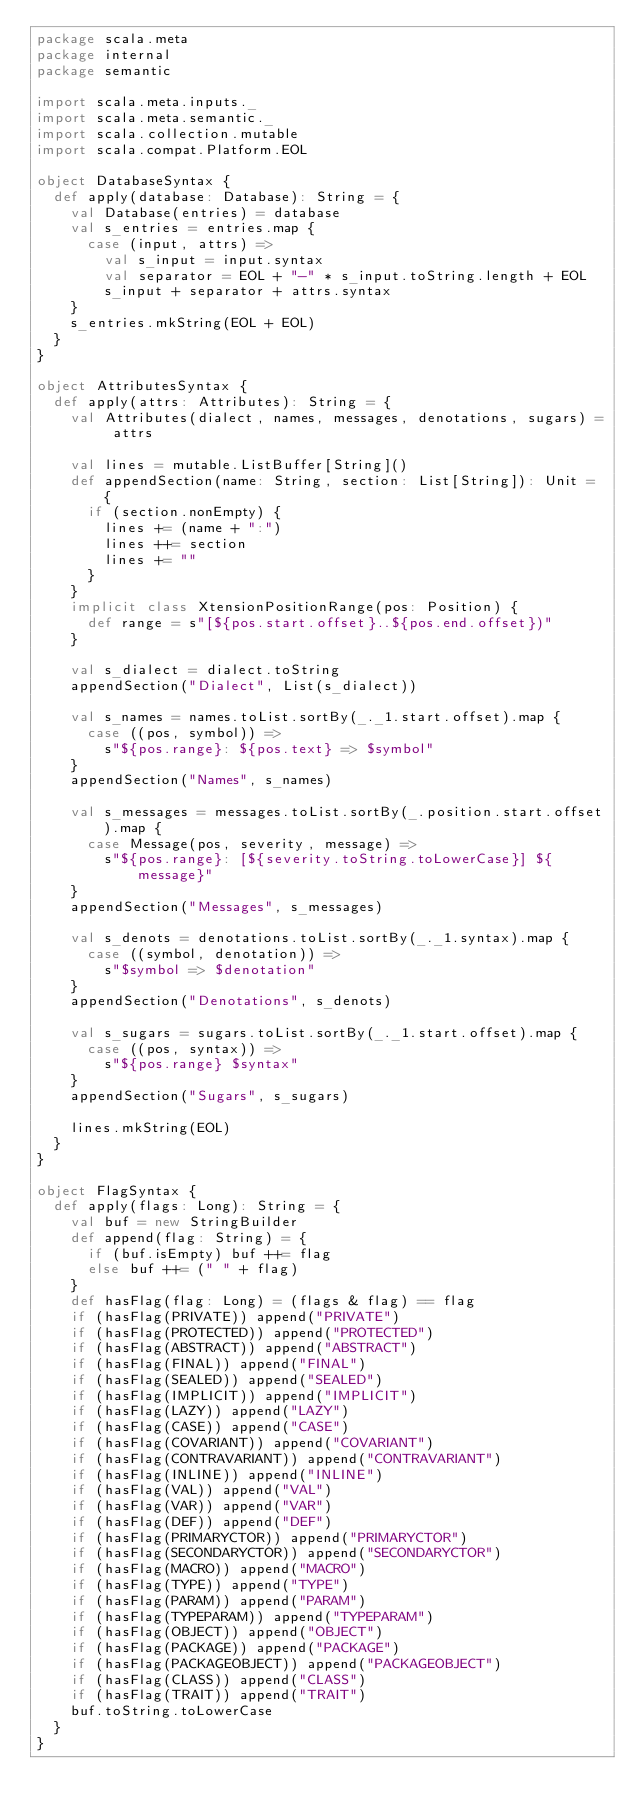Convert code to text. <code><loc_0><loc_0><loc_500><loc_500><_Scala_>package scala.meta
package internal
package semantic

import scala.meta.inputs._
import scala.meta.semantic._
import scala.collection.mutable
import scala.compat.Platform.EOL

object DatabaseSyntax {
  def apply(database: Database): String = {
    val Database(entries) = database
    val s_entries = entries.map {
      case (input, attrs) =>
        val s_input = input.syntax
        val separator = EOL + "-" * s_input.toString.length + EOL
        s_input + separator + attrs.syntax
    }
    s_entries.mkString(EOL + EOL)
  }
}

object AttributesSyntax {
  def apply(attrs: Attributes): String = {
    val Attributes(dialect, names, messages, denotations, sugars) = attrs

    val lines = mutable.ListBuffer[String]()
    def appendSection(name: String, section: List[String]): Unit = {
      if (section.nonEmpty) {
        lines += (name + ":")
        lines ++= section
        lines += ""
      }
    }
    implicit class XtensionPositionRange(pos: Position) {
      def range = s"[${pos.start.offset}..${pos.end.offset})"
    }

    val s_dialect = dialect.toString
    appendSection("Dialect", List(s_dialect))

    val s_names = names.toList.sortBy(_._1.start.offset).map {
      case ((pos, symbol)) =>
        s"${pos.range}: ${pos.text} => $symbol"
    }
    appendSection("Names", s_names)

    val s_messages = messages.toList.sortBy(_.position.start.offset).map {
      case Message(pos, severity, message) =>
        s"${pos.range}: [${severity.toString.toLowerCase}] ${message}"
    }
    appendSection("Messages", s_messages)

    val s_denots = denotations.toList.sortBy(_._1.syntax).map {
      case ((symbol, denotation)) =>
        s"$symbol => $denotation"
    }
    appendSection("Denotations", s_denots)

    val s_sugars = sugars.toList.sortBy(_._1.start.offset).map {
      case ((pos, syntax)) =>
        s"${pos.range} $syntax"
    }
    appendSection("Sugars", s_sugars)

    lines.mkString(EOL)
  }
}

object FlagSyntax {
  def apply(flags: Long): String = {
    val buf = new StringBuilder
    def append(flag: String) = {
      if (buf.isEmpty) buf ++= flag
      else buf ++= (" " + flag)
    }
    def hasFlag(flag: Long) = (flags & flag) == flag
    if (hasFlag(PRIVATE)) append("PRIVATE")
    if (hasFlag(PROTECTED)) append("PROTECTED")
    if (hasFlag(ABSTRACT)) append("ABSTRACT")
    if (hasFlag(FINAL)) append("FINAL")
    if (hasFlag(SEALED)) append("SEALED")
    if (hasFlag(IMPLICIT)) append("IMPLICIT")
    if (hasFlag(LAZY)) append("LAZY")
    if (hasFlag(CASE)) append("CASE")
    if (hasFlag(COVARIANT)) append("COVARIANT")
    if (hasFlag(CONTRAVARIANT)) append("CONTRAVARIANT")
    if (hasFlag(INLINE)) append("INLINE")
    if (hasFlag(VAL)) append("VAL")
    if (hasFlag(VAR)) append("VAR")
    if (hasFlag(DEF)) append("DEF")
    if (hasFlag(PRIMARYCTOR)) append("PRIMARYCTOR")
    if (hasFlag(SECONDARYCTOR)) append("SECONDARYCTOR")
    if (hasFlag(MACRO)) append("MACRO")
    if (hasFlag(TYPE)) append("TYPE")
    if (hasFlag(PARAM)) append("PARAM")
    if (hasFlag(TYPEPARAM)) append("TYPEPARAM")
    if (hasFlag(OBJECT)) append("OBJECT")
    if (hasFlag(PACKAGE)) append("PACKAGE")
    if (hasFlag(PACKAGEOBJECT)) append("PACKAGEOBJECT")
    if (hasFlag(CLASS)) append("CLASS")
    if (hasFlag(TRAIT)) append("TRAIT")
    buf.toString.toLowerCase
  }
}</code> 